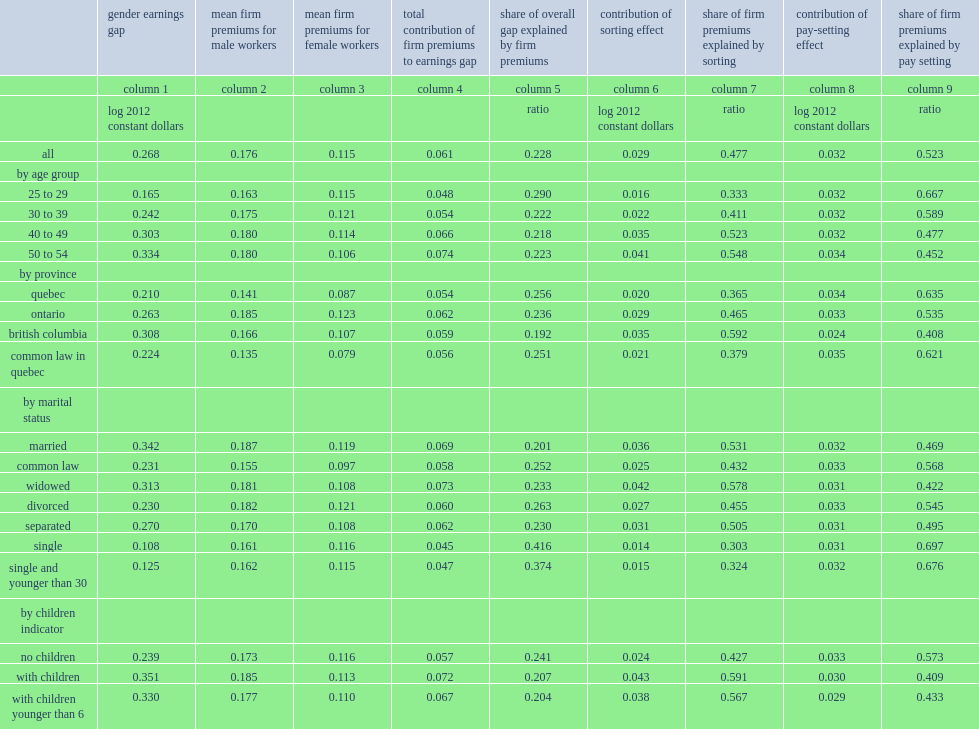What was the percentage of an average earnings gap between male and female workers? 0.268. With regard to the overall contribution of firm effects to the gender earnings gap, what was the percentage of the gap attributable to the share of earnings specific to the firm? 0.228. 